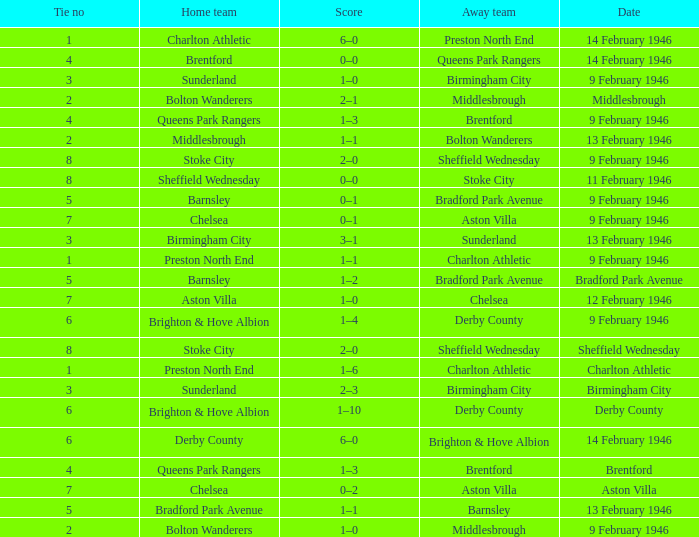What was the highest Tie no when the home team was the Bolton Wanderers, and the date was Middlesbrough? 2.0. Help me parse the entirety of this table. {'header': ['Tie no', 'Home team', 'Score', 'Away team', 'Date'], 'rows': [['1', 'Charlton Athletic', '6–0', 'Preston North End', '14 February 1946'], ['4', 'Brentford', '0–0', 'Queens Park Rangers', '14 February 1946'], ['3', 'Sunderland', '1–0', 'Birmingham City', '9 February 1946'], ['2', 'Bolton Wanderers', '2–1', 'Middlesbrough', 'Middlesbrough'], ['4', 'Queens Park Rangers', '1–3', 'Brentford', '9 February 1946'], ['2', 'Middlesbrough', '1–1', 'Bolton Wanderers', '13 February 1946'], ['8', 'Stoke City', '2–0', 'Sheffield Wednesday', '9 February 1946'], ['8', 'Sheffield Wednesday', '0–0', 'Stoke City', '11 February 1946'], ['5', 'Barnsley', '0–1', 'Bradford Park Avenue', '9 February 1946'], ['7', 'Chelsea', '0–1', 'Aston Villa', '9 February 1946'], ['3', 'Birmingham City', '3–1', 'Sunderland', '13 February 1946'], ['1', 'Preston North End', '1–1', 'Charlton Athletic', '9 February 1946'], ['5', 'Barnsley', '1–2', 'Bradford Park Avenue', 'Bradford Park Avenue'], ['7', 'Aston Villa', '1–0', 'Chelsea', '12 February 1946'], ['6', 'Brighton & Hove Albion', '1–4', 'Derby County', '9 February 1946'], ['8', 'Stoke City', '2–0', 'Sheffield Wednesday', 'Sheffield Wednesday'], ['1', 'Preston North End', '1–6', 'Charlton Athletic', 'Charlton Athletic'], ['3', 'Sunderland', '2–3', 'Birmingham City', 'Birmingham City'], ['6', 'Brighton & Hove Albion', '1–10', 'Derby County', 'Derby County'], ['6', 'Derby County', '6–0', 'Brighton & Hove Albion', '14 February 1946'], ['4', 'Queens Park Rangers', '1–3', 'Brentford', 'Brentford'], ['7', 'Chelsea', '0–2', 'Aston Villa', 'Aston Villa'], ['5', 'Bradford Park Avenue', '1–1', 'Barnsley', '13 February 1946'], ['2', 'Bolton Wanderers', '1–0', 'Middlesbrough', '9 February 1946']]} 